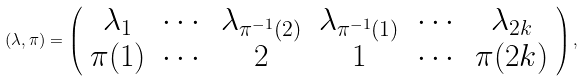Convert formula to latex. <formula><loc_0><loc_0><loc_500><loc_500>( \lambda , \pi ) = \left ( \begin{array} { c c c c c c } \lambda _ { 1 } & \cdots & \lambda _ { \pi ^ { - 1 } ( 2 ) } & \lambda _ { \pi ^ { - 1 } ( 1 ) } & \cdots & \lambda _ { 2 k } \\ \pi ( 1 ) & \cdots & 2 & 1 & \cdots & \pi ( 2 k ) \end{array} \right ) ,</formula> 